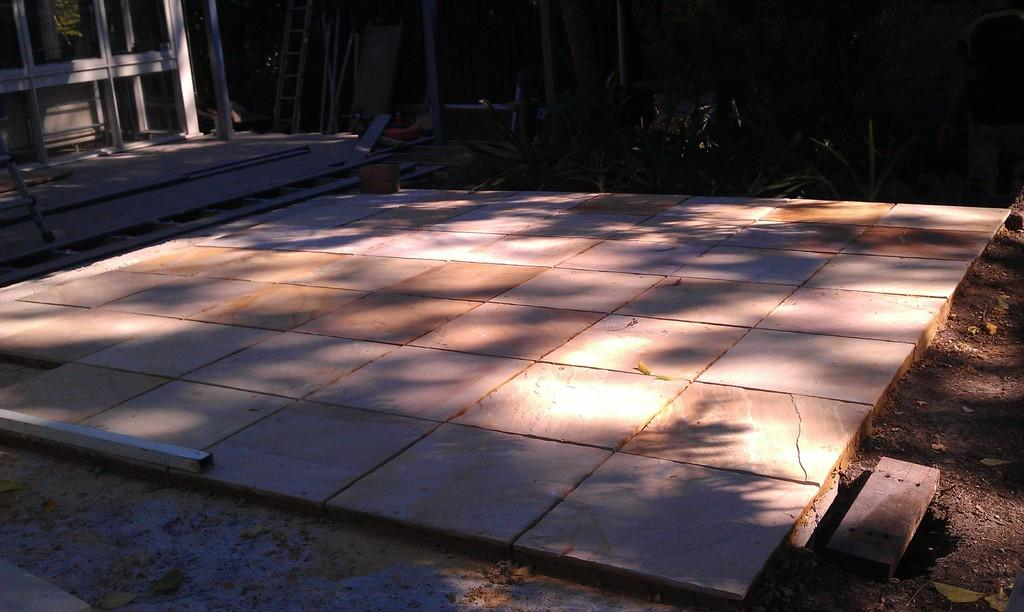What type of flooring is visible in the image? The floor has tiles. What can be seen in the background of the image? There are plants in the background. What is the purpose of the ladder in the image? The ladder's purpose is not explicitly stated, but it is likely used for reaching higher areas. What are the rods used for in the image? The purpose of the rods is not explicitly stated, but they may be used for support or hanging objects. What material are the wooden pieces made of? The wooden pieces are made of wood. How many ducks are sitting on the wooden pieces in the image? There are no ducks present in the image. What account number is associated with the wooden pieces in the image? There is no account number associated with the wooden pieces in the image. 